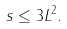Convert formula to latex. <formula><loc_0><loc_0><loc_500><loc_500>s \leq 3 L ^ { 2 } .</formula> 